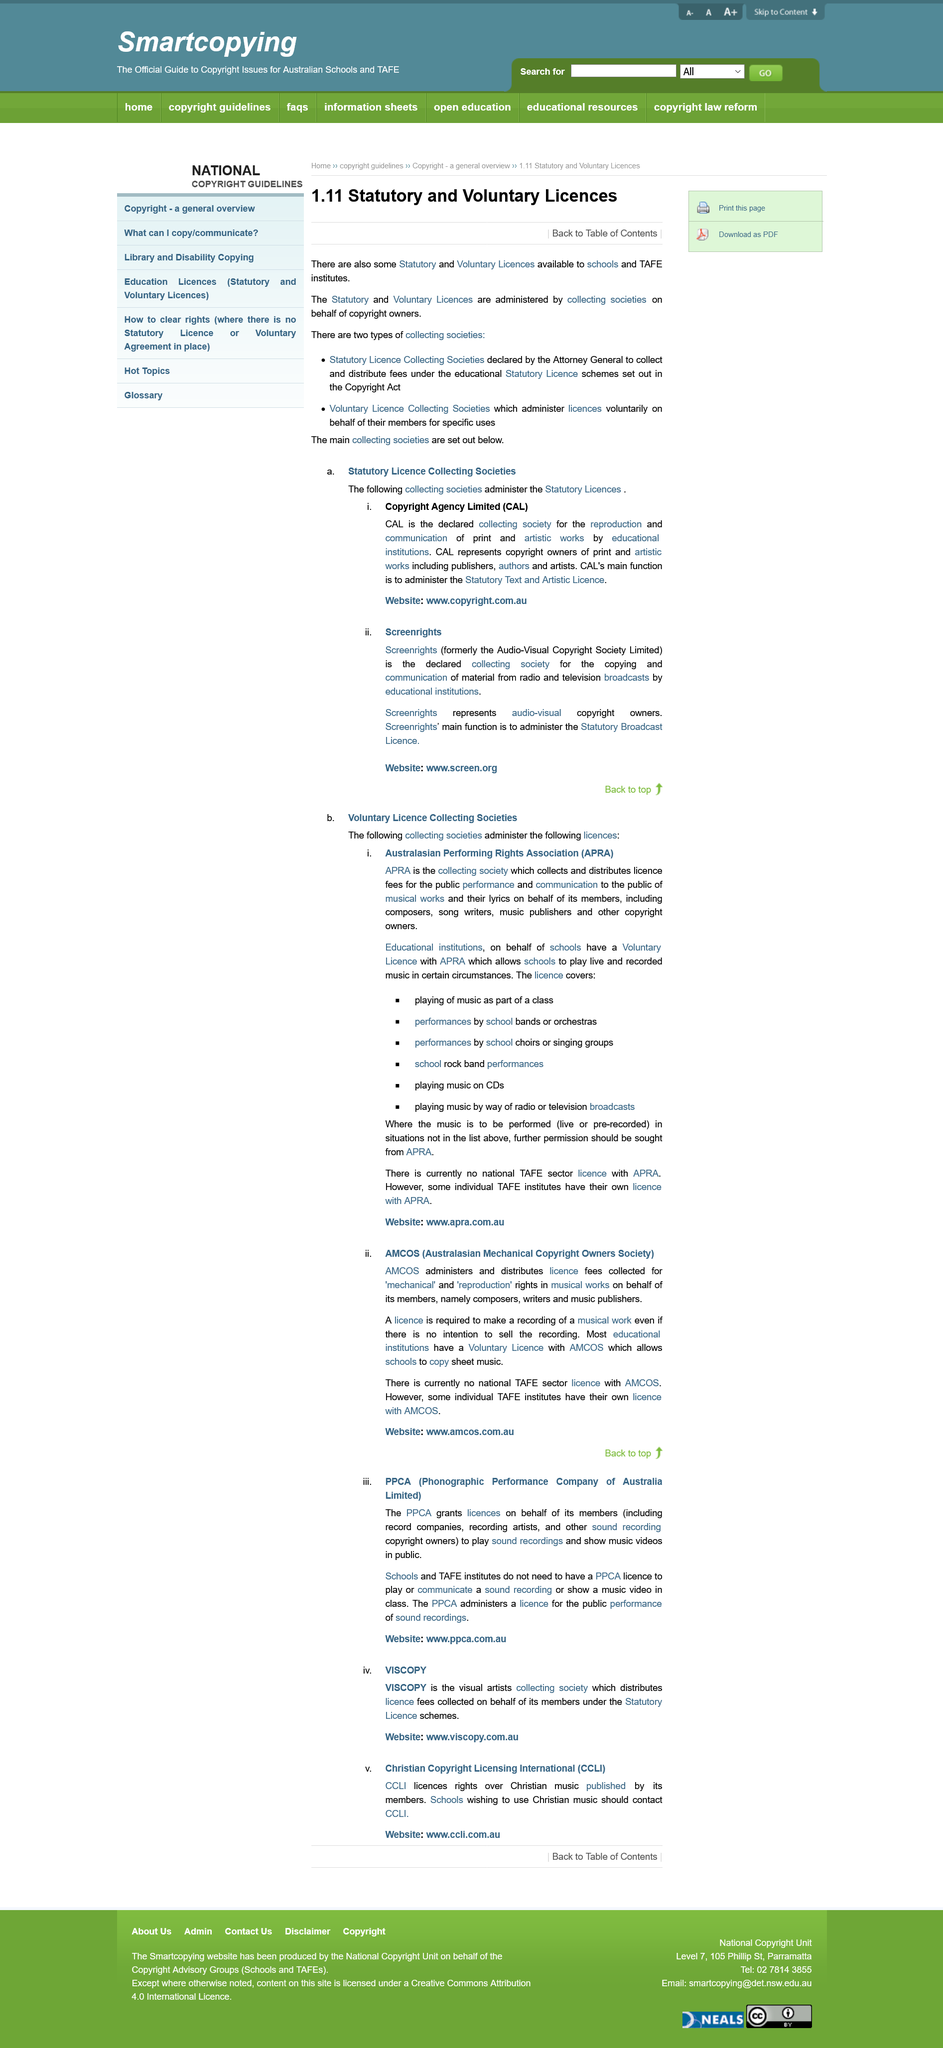Give some essential details in this illustration. There are two types of collecting societies that exist: Statutory Licence Collecting Societies and Voluntary Licence Collecting Societies. CAL's main function is to administer the Statutory Text and Artistic Licence. Copyright Agency Limited is an acronym that stands for "CAL. 